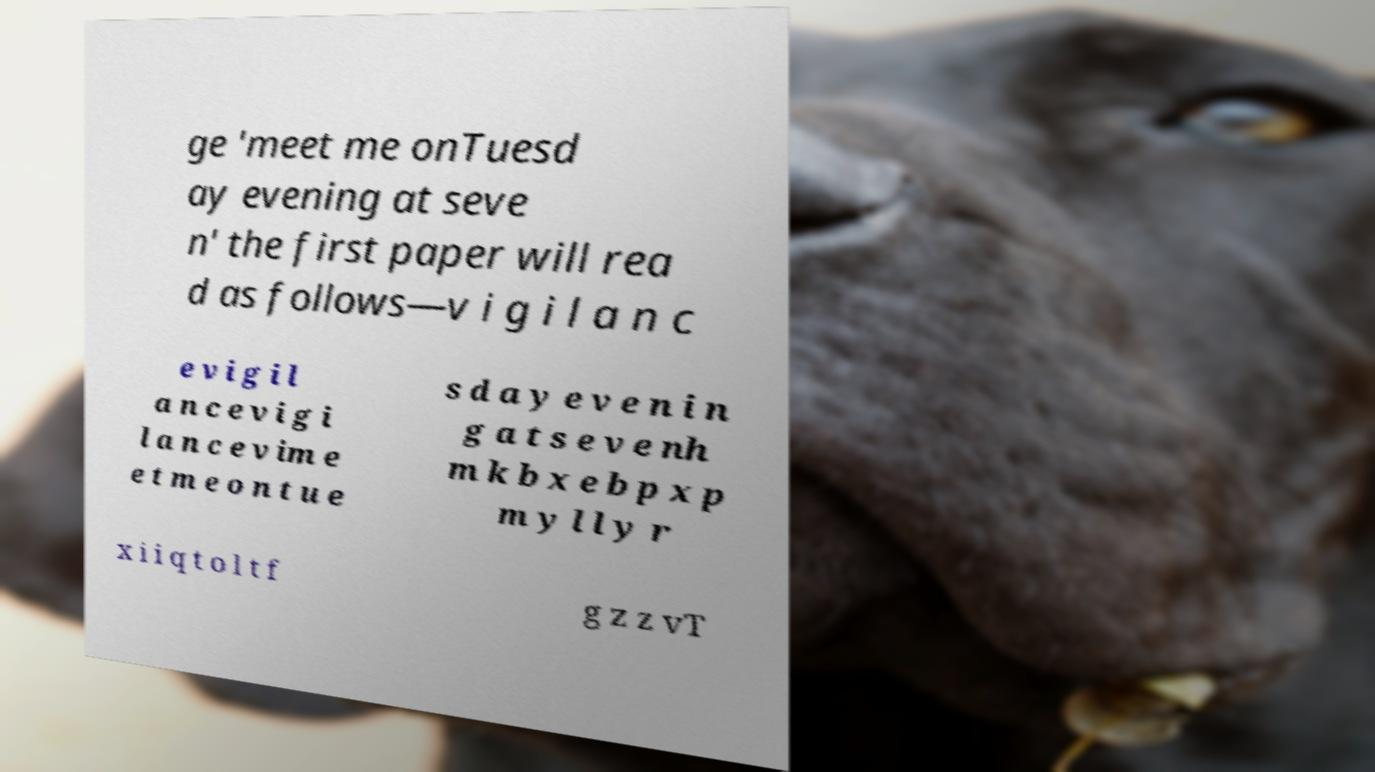For documentation purposes, I need the text within this image transcribed. Could you provide that? ge 'meet me onTuesd ay evening at seve n' the first paper will rea d as follows—v i g i l a n c e v i g i l a n c e v i g i l a n c e v im e e t m e o n t u e s d a y e v e n i n g a t s e v e nh m k b x e b p x p m y l l y r x i i q t o l t f g z z vT 